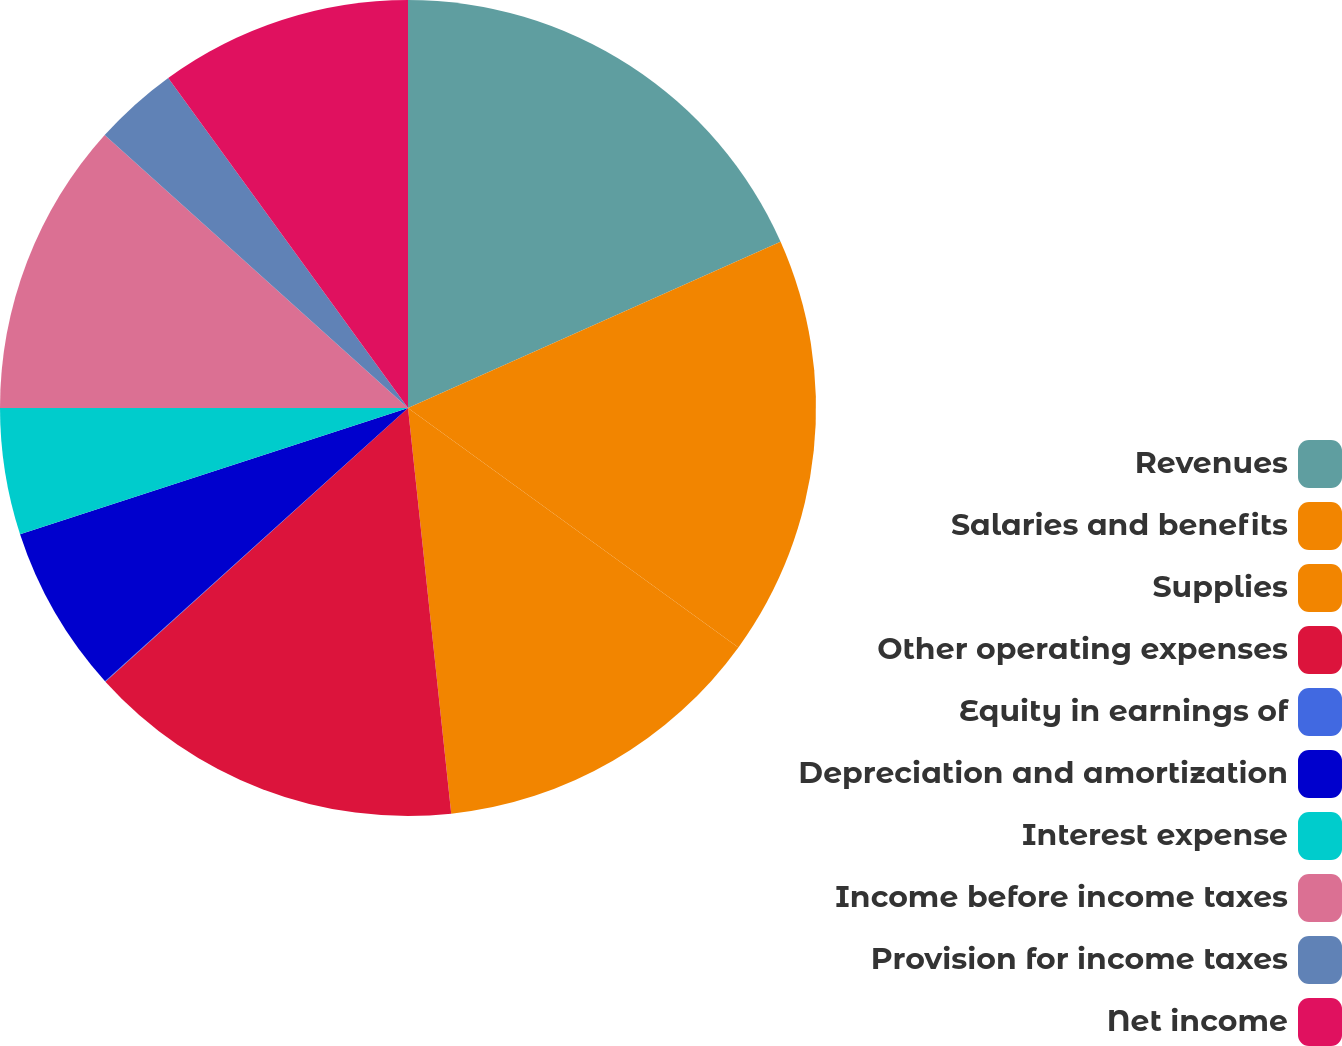Convert chart to OTSL. <chart><loc_0><loc_0><loc_500><loc_500><pie_chart><fcel>Revenues<fcel>Salaries and benefits<fcel>Supplies<fcel>Other operating expenses<fcel>Equity in earnings of<fcel>Depreciation and amortization<fcel>Interest expense<fcel>Income before income taxes<fcel>Provision for income taxes<fcel>Net income<nl><fcel>18.32%<fcel>16.66%<fcel>13.33%<fcel>14.99%<fcel>0.02%<fcel>6.67%<fcel>5.01%<fcel>11.66%<fcel>3.34%<fcel>10.0%<nl></chart> 